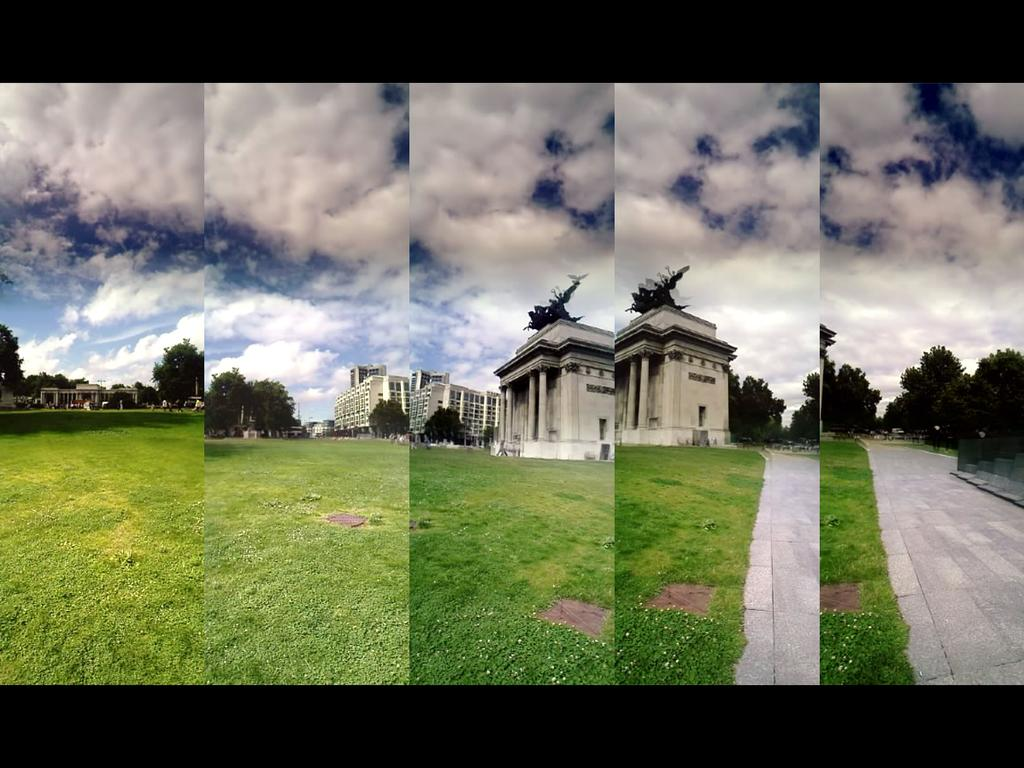What type of artwork is the image? The image is a collage. What structures are depicted in the collage? There are buildings in the image. What type of vegetation can be seen in the collage? There is grass and trees in the image. What is visible in the background of the collage? The sky is visible in the background of the image. What type of drink is being served in the image? There is no drink present in the image; it is a collage featuring buildings, grass, trees, and the sky. What color are the jeans worn by the person in the image? There is no person wearing jeans in the image, as it is a collage of buildings, grass, trees, and the sky. 